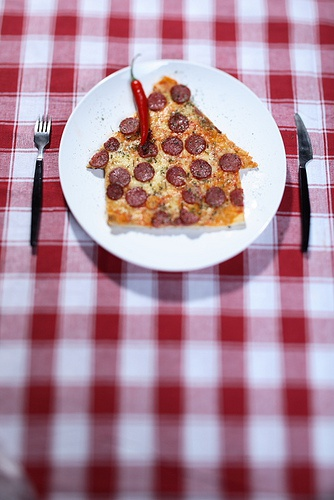Describe the objects in this image and their specific colors. I can see dining table in lavender, brown, darkgray, and gray tones, pizza in lavender, brown, tan, and maroon tones, fork in lavender, black, gray, white, and darkgray tones, and knife in lavender, black, and gray tones in this image. 